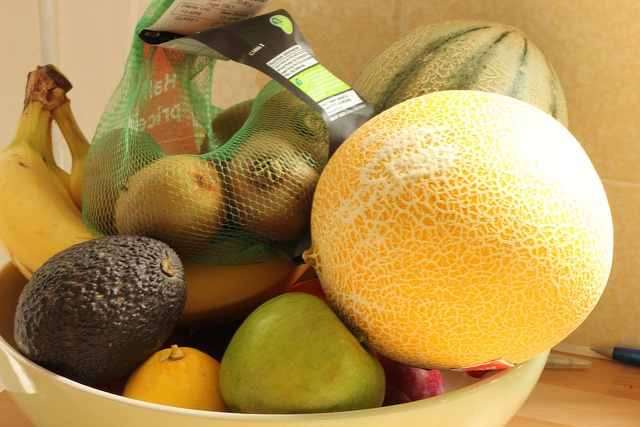Describe the objects in this image and their specific colors. I can see dining table in tan, orange, olive, and black tones, bowl in tan, khaki, black, and maroon tones, apple in tan, olive, and black tones, banana in tan, orange, and olive tones, and orange in tan, orange, red, and maroon tones in this image. 